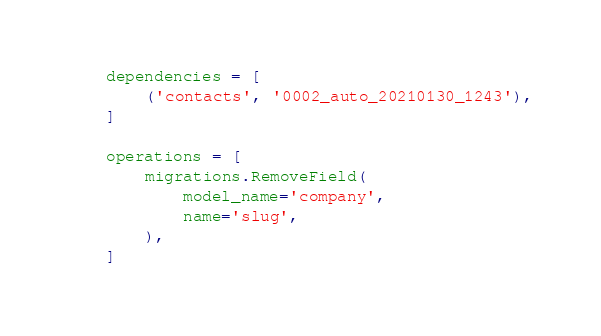Convert code to text. <code><loc_0><loc_0><loc_500><loc_500><_Python_>    dependencies = [
        ('contacts', '0002_auto_20210130_1243'),
    ]

    operations = [
        migrations.RemoveField(
            model_name='company',
            name='slug',
        ),
    ]
</code> 